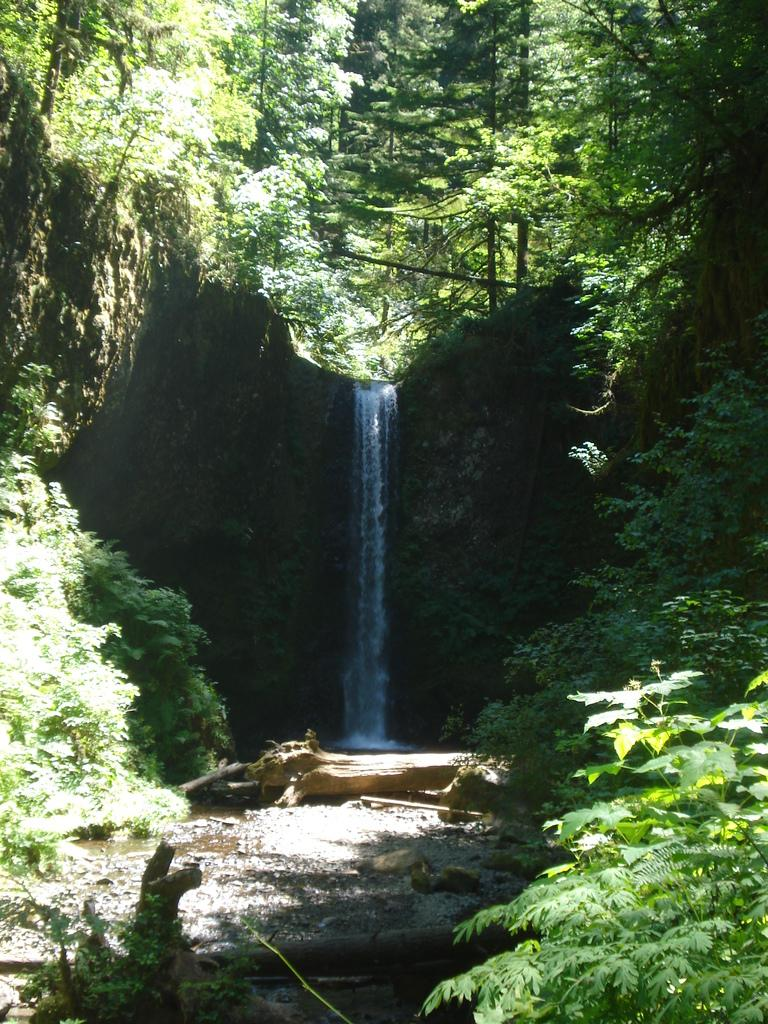What can be seen in the left corner of the image? There are trees in the left corner of the image. What can be seen in the right corner of the image? There are trees in the right corner of the image. What is located at the bottom of the image? There is water at the bottom of the image. What natural feature is present in the image? There is a waterfall in the image. What type of vegetation is visible in the background of the image? There are trees in the background of the image. What is visible at the top of the image? The sky is visible at the top of the image. What type of loaf can be seen in the image? There is no loaf present in the image. What kind of drug is being used by the trees in the image? There is no drug use depicted in the image, as it features trees and a waterfall. 